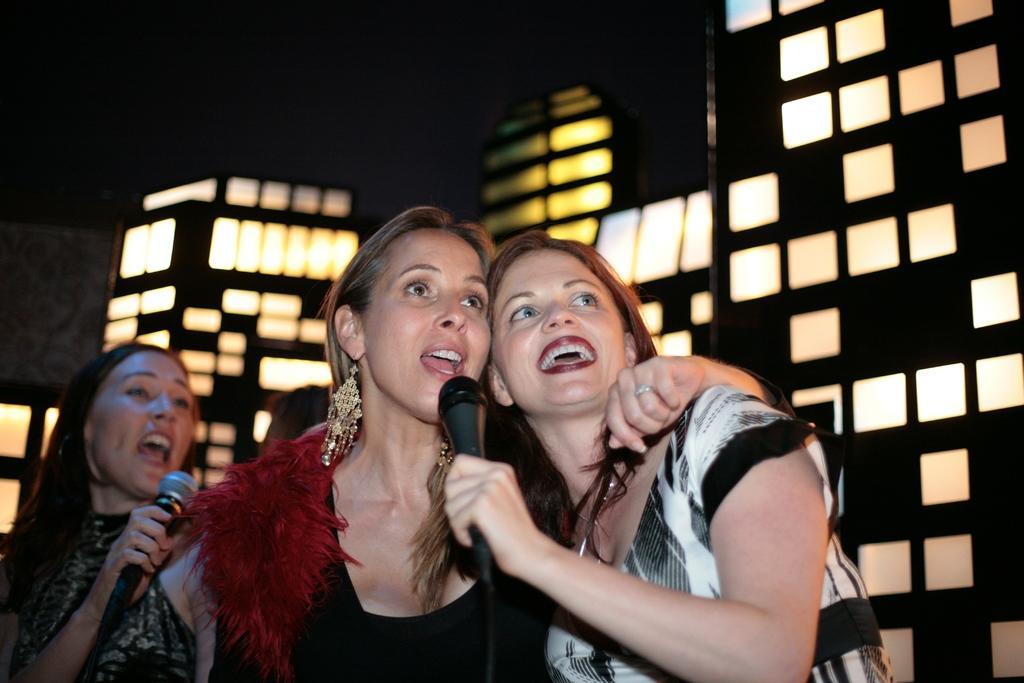Describe this image in one or two sentences. There are three women in this picture. There are two mics in their hands. All of them were singing. In the background there is a wall with some design here. 